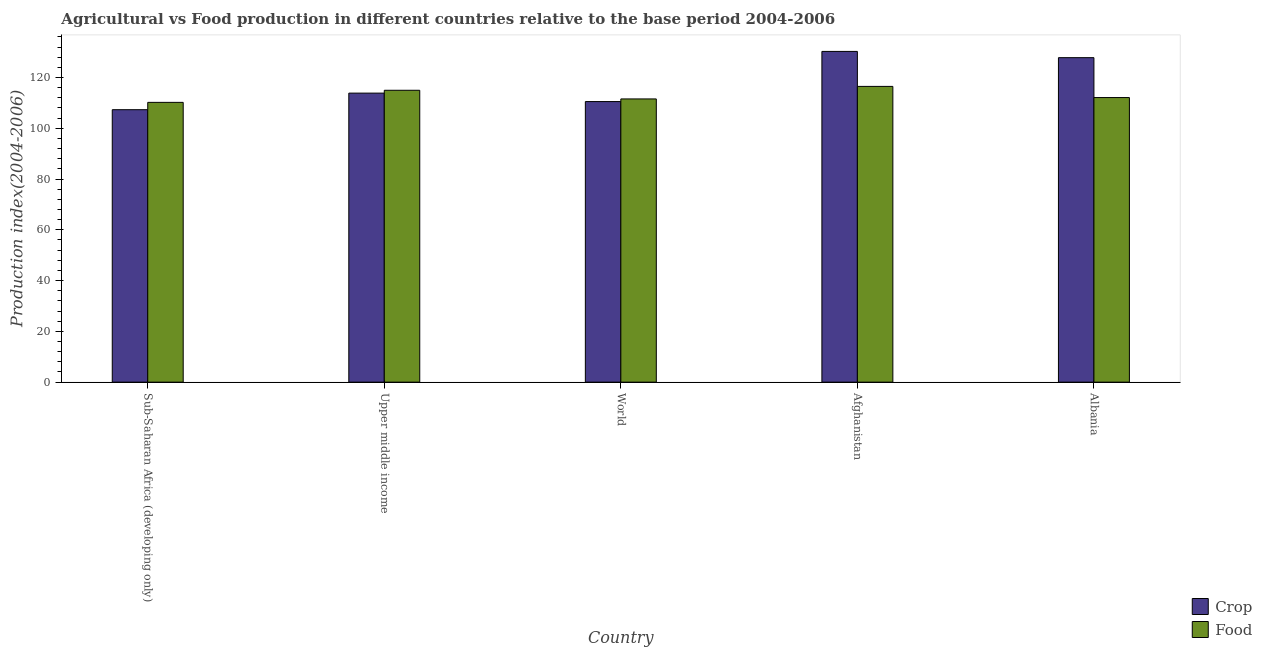Are the number of bars on each tick of the X-axis equal?
Your answer should be compact. Yes. What is the label of the 1st group of bars from the left?
Your answer should be very brief. Sub-Saharan Africa (developing only). What is the crop production index in Afghanistan?
Your answer should be very brief. 130.29. Across all countries, what is the maximum food production index?
Your answer should be very brief. 116.51. Across all countries, what is the minimum food production index?
Your response must be concise. 110.22. In which country was the crop production index maximum?
Offer a very short reply. Afghanistan. In which country was the food production index minimum?
Offer a very short reply. Sub-Saharan Africa (developing only). What is the total food production index in the graph?
Ensure brevity in your answer.  565.39. What is the difference between the food production index in Afghanistan and that in Albania?
Offer a terse response. 4.4. What is the difference between the food production index in Sub-Saharan Africa (developing only) and the crop production index in Upper middle income?
Your answer should be compact. -3.64. What is the average crop production index per country?
Keep it short and to the point. 117.97. What is the difference between the food production index and crop production index in Albania?
Your response must be concise. -15.72. What is the ratio of the food production index in Afghanistan to that in Sub-Saharan Africa (developing only)?
Keep it short and to the point. 1.06. What is the difference between the highest and the second highest food production index?
Your answer should be very brief. 1.53. What is the difference between the highest and the lowest crop production index?
Give a very brief answer. 22.96. What does the 1st bar from the left in Sub-Saharan Africa (developing only) represents?
Your response must be concise. Crop. What does the 1st bar from the right in Afghanistan represents?
Offer a terse response. Food. Are the values on the major ticks of Y-axis written in scientific E-notation?
Your answer should be compact. No. Does the graph contain any zero values?
Provide a short and direct response. No. Does the graph contain grids?
Your answer should be very brief. No. Where does the legend appear in the graph?
Offer a very short reply. Bottom right. What is the title of the graph?
Provide a short and direct response. Agricultural vs Food production in different countries relative to the base period 2004-2006. What is the label or title of the Y-axis?
Offer a very short reply. Production index(2004-2006). What is the Production index(2004-2006) in Crop in Sub-Saharan Africa (developing only)?
Ensure brevity in your answer.  107.33. What is the Production index(2004-2006) in Food in Sub-Saharan Africa (developing only)?
Provide a short and direct response. 110.22. What is the Production index(2004-2006) of Crop in Upper middle income?
Your answer should be compact. 113.86. What is the Production index(2004-2006) of Food in Upper middle income?
Make the answer very short. 114.98. What is the Production index(2004-2006) of Crop in World?
Offer a very short reply. 110.53. What is the Production index(2004-2006) in Food in World?
Keep it short and to the point. 111.57. What is the Production index(2004-2006) in Crop in Afghanistan?
Provide a short and direct response. 130.29. What is the Production index(2004-2006) of Food in Afghanistan?
Give a very brief answer. 116.51. What is the Production index(2004-2006) of Crop in Albania?
Offer a very short reply. 127.83. What is the Production index(2004-2006) of Food in Albania?
Provide a short and direct response. 112.11. Across all countries, what is the maximum Production index(2004-2006) of Crop?
Ensure brevity in your answer.  130.29. Across all countries, what is the maximum Production index(2004-2006) in Food?
Offer a very short reply. 116.51. Across all countries, what is the minimum Production index(2004-2006) in Crop?
Make the answer very short. 107.33. Across all countries, what is the minimum Production index(2004-2006) in Food?
Your response must be concise. 110.22. What is the total Production index(2004-2006) of Crop in the graph?
Give a very brief answer. 589.85. What is the total Production index(2004-2006) of Food in the graph?
Your response must be concise. 565.39. What is the difference between the Production index(2004-2006) in Crop in Sub-Saharan Africa (developing only) and that in Upper middle income?
Keep it short and to the point. -6.53. What is the difference between the Production index(2004-2006) in Food in Sub-Saharan Africa (developing only) and that in Upper middle income?
Make the answer very short. -4.76. What is the difference between the Production index(2004-2006) of Crop in Sub-Saharan Africa (developing only) and that in World?
Make the answer very short. -3.2. What is the difference between the Production index(2004-2006) in Food in Sub-Saharan Africa (developing only) and that in World?
Give a very brief answer. -1.36. What is the difference between the Production index(2004-2006) in Crop in Sub-Saharan Africa (developing only) and that in Afghanistan?
Give a very brief answer. -22.96. What is the difference between the Production index(2004-2006) of Food in Sub-Saharan Africa (developing only) and that in Afghanistan?
Your answer should be compact. -6.29. What is the difference between the Production index(2004-2006) in Crop in Sub-Saharan Africa (developing only) and that in Albania?
Your response must be concise. -20.5. What is the difference between the Production index(2004-2006) in Food in Sub-Saharan Africa (developing only) and that in Albania?
Provide a succinct answer. -1.89. What is the difference between the Production index(2004-2006) in Crop in Upper middle income and that in World?
Ensure brevity in your answer.  3.33. What is the difference between the Production index(2004-2006) in Food in Upper middle income and that in World?
Provide a succinct answer. 3.41. What is the difference between the Production index(2004-2006) in Crop in Upper middle income and that in Afghanistan?
Your response must be concise. -16.43. What is the difference between the Production index(2004-2006) in Food in Upper middle income and that in Afghanistan?
Give a very brief answer. -1.53. What is the difference between the Production index(2004-2006) of Crop in Upper middle income and that in Albania?
Make the answer very short. -13.97. What is the difference between the Production index(2004-2006) of Food in Upper middle income and that in Albania?
Your answer should be compact. 2.87. What is the difference between the Production index(2004-2006) of Crop in World and that in Afghanistan?
Your response must be concise. -19.76. What is the difference between the Production index(2004-2006) of Food in World and that in Afghanistan?
Offer a very short reply. -4.94. What is the difference between the Production index(2004-2006) of Crop in World and that in Albania?
Offer a very short reply. -17.3. What is the difference between the Production index(2004-2006) of Food in World and that in Albania?
Offer a terse response. -0.54. What is the difference between the Production index(2004-2006) in Crop in Afghanistan and that in Albania?
Offer a terse response. 2.46. What is the difference between the Production index(2004-2006) of Food in Afghanistan and that in Albania?
Provide a short and direct response. 4.4. What is the difference between the Production index(2004-2006) in Crop in Sub-Saharan Africa (developing only) and the Production index(2004-2006) in Food in Upper middle income?
Ensure brevity in your answer.  -7.65. What is the difference between the Production index(2004-2006) of Crop in Sub-Saharan Africa (developing only) and the Production index(2004-2006) of Food in World?
Give a very brief answer. -4.24. What is the difference between the Production index(2004-2006) in Crop in Sub-Saharan Africa (developing only) and the Production index(2004-2006) in Food in Afghanistan?
Your answer should be compact. -9.18. What is the difference between the Production index(2004-2006) in Crop in Sub-Saharan Africa (developing only) and the Production index(2004-2006) in Food in Albania?
Provide a succinct answer. -4.78. What is the difference between the Production index(2004-2006) of Crop in Upper middle income and the Production index(2004-2006) of Food in World?
Offer a very short reply. 2.29. What is the difference between the Production index(2004-2006) of Crop in Upper middle income and the Production index(2004-2006) of Food in Afghanistan?
Provide a short and direct response. -2.65. What is the difference between the Production index(2004-2006) of Crop in Upper middle income and the Production index(2004-2006) of Food in Albania?
Offer a very short reply. 1.75. What is the difference between the Production index(2004-2006) of Crop in World and the Production index(2004-2006) of Food in Afghanistan?
Your answer should be compact. -5.98. What is the difference between the Production index(2004-2006) of Crop in World and the Production index(2004-2006) of Food in Albania?
Make the answer very short. -1.58. What is the difference between the Production index(2004-2006) of Crop in Afghanistan and the Production index(2004-2006) of Food in Albania?
Your response must be concise. 18.18. What is the average Production index(2004-2006) in Crop per country?
Provide a short and direct response. 117.97. What is the average Production index(2004-2006) of Food per country?
Your answer should be very brief. 113.08. What is the difference between the Production index(2004-2006) of Crop and Production index(2004-2006) of Food in Sub-Saharan Africa (developing only)?
Make the answer very short. -2.89. What is the difference between the Production index(2004-2006) in Crop and Production index(2004-2006) in Food in Upper middle income?
Your answer should be very brief. -1.12. What is the difference between the Production index(2004-2006) in Crop and Production index(2004-2006) in Food in World?
Offer a very short reply. -1.04. What is the difference between the Production index(2004-2006) in Crop and Production index(2004-2006) in Food in Afghanistan?
Keep it short and to the point. 13.78. What is the difference between the Production index(2004-2006) in Crop and Production index(2004-2006) in Food in Albania?
Your answer should be very brief. 15.72. What is the ratio of the Production index(2004-2006) of Crop in Sub-Saharan Africa (developing only) to that in Upper middle income?
Your response must be concise. 0.94. What is the ratio of the Production index(2004-2006) in Food in Sub-Saharan Africa (developing only) to that in Upper middle income?
Keep it short and to the point. 0.96. What is the ratio of the Production index(2004-2006) in Food in Sub-Saharan Africa (developing only) to that in World?
Make the answer very short. 0.99. What is the ratio of the Production index(2004-2006) of Crop in Sub-Saharan Africa (developing only) to that in Afghanistan?
Your answer should be compact. 0.82. What is the ratio of the Production index(2004-2006) of Food in Sub-Saharan Africa (developing only) to that in Afghanistan?
Provide a short and direct response. 0.95. What is the ratio of the Production index(2004-2006) of Crop in Sub-Saharan Africa (developing only) to that in Albania?
Keep it short and to the point. 0.84. What is the ratio of the Production index(2004-2006) in Food in Sub-Saharan Africa (developing only) to that in Albania?
Your answer should be compact. 0.98. What is the ratio of the Production index(2004-2006) in Crop in Upper middle income to that in World?
Your answer should be compact. 1.03. What is the ratio of the Production index(2004-2006) of Food in Upper middle income to that in World?
Offer a terse response. 1.03. What is the ratio of the Production index(2004-2006) in Crop in Upper middle income to that in Afghanistan?
Your answer should be compact. 0.87. What is the ratio of the Production index(2004-2006) of Food in Upper middle income to that in Afghanistan?
Make the answer very short. 0.99. What is the ratio of the Production index(2004-2006) of Crop in Upper middle income to that in Albania?
Provide a short and direct response. 0.89. What is the ratio of the Production index(2004-2006) in Food in Upper middle income to that in Albania?
Offer a very short reply. 1.03. What is the ratio of the Production index(2004-2006) of Crop in World to that in Afghanistan?
Give a very brief answer. 0.85. What is the ratio of the Production index(2004-2006) in Food in World to that in Afghanistan?
Your answer should be very brief. 0.96. What is the ratio of the Production index(2004-2006) in Crop in World to that in Albania?
Provide a short and direct response. 0.86. What is the ratio of the Production index(2004-2006) in Crop in Afghanistan to that in Albania?
Offer a very short reply. 1.02. What is the ratio of the Production index(2004-2006) of Food in Afghanistan to that in Albania?
Your answer should be compact. 1.04. What is the difference between the highest and the second highest Production index(2004-2006) of Crop?
Ensure brevity in your answer.  2.46. What is the difference between the highest and the second highest Production index(2004-2006) of Food?
Your answer should be very brief. 1.53. What is the difference between the highest and the lowest Production index(2004-2006) in Crop?
Provide a succinct answer. 22.96. What is the difference between the highest and the lowest Production index(2004-2006) of Food?
Provide a short and direct response. 6.29. 